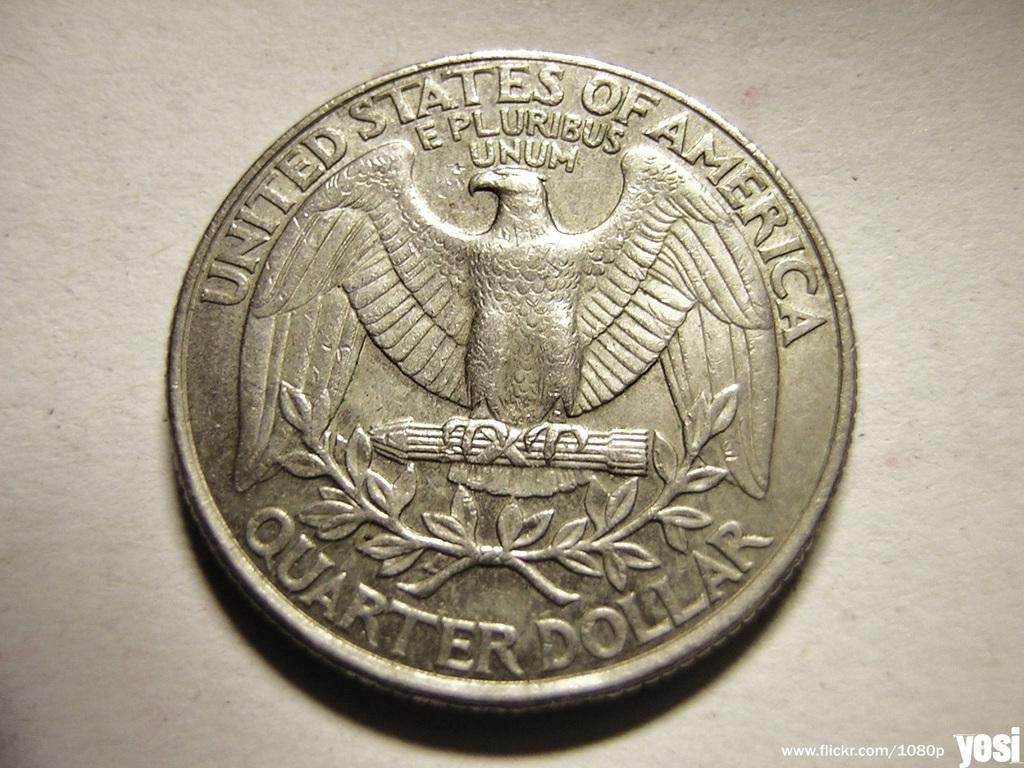<image>
Present a compact description of the photo's key features. a United States of America QUARTER DOLLAR. 